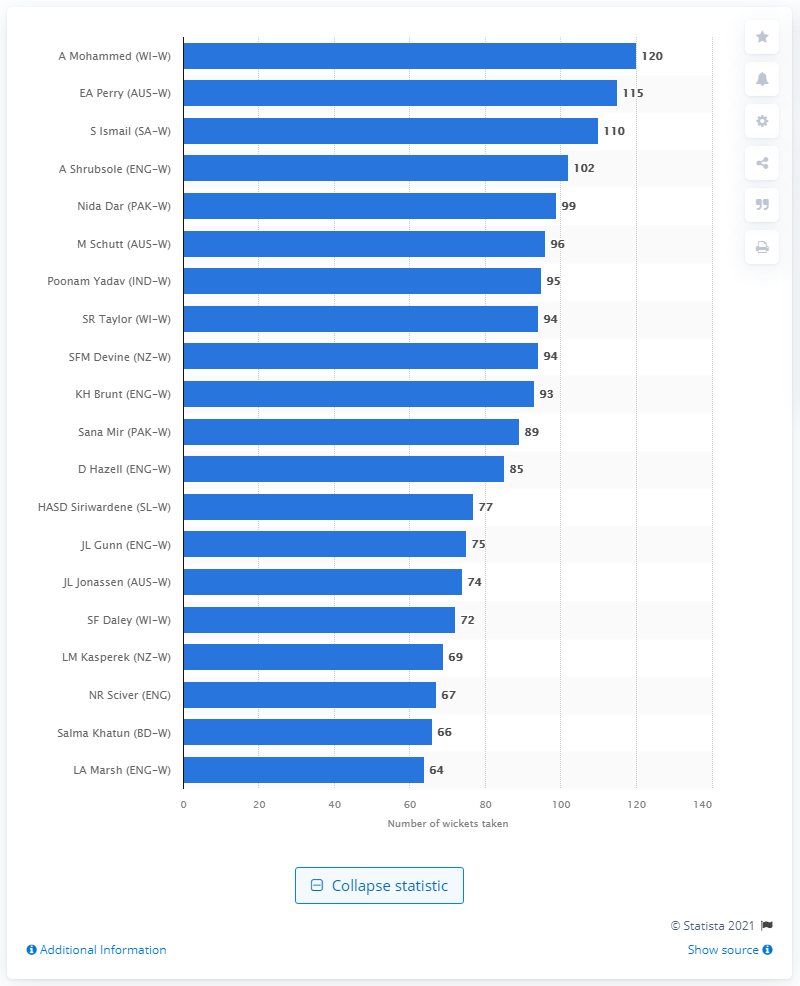Identify some key points in this picture. Since 2008, Anisa Mohammed has taken a total of 120 wickets. 